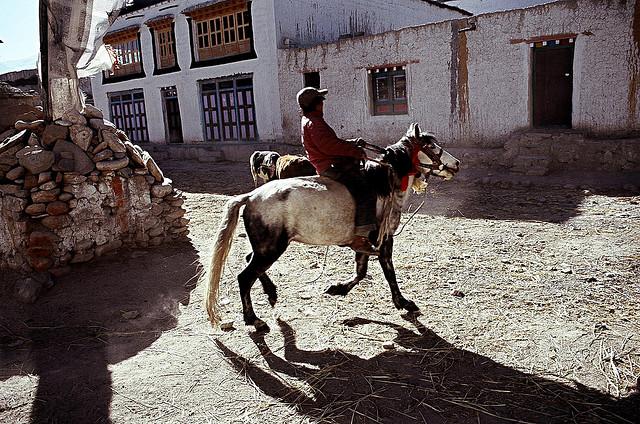How many horses are in the picture?
Give a very brief answer. 1. How many horses are there in the image?
Give a very brief answer. 1. Is the horses shadow long or short?
Answer briefly. Long. 